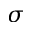Convert formula to latex. <formula><loc_0><loc_0><loc_500><loc_500>\sigma</formula> 